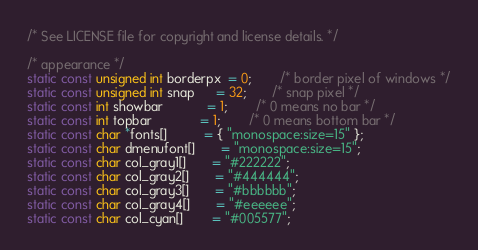<code> <loc_0><loc_0><loc_500><loc_500><_C_>/* See LICENSE file for copyright and license details. */

/* appearance */
static const unsigned int borderpx  = 0;        /* border pixel of windows */
static const unsigned int snap      = 32;       /* snap pixel */
static const int showbar            = 1;        /* 0 means no bar */
static const int topbar             = 1;        /* 0 means bottom bar */
static const char *fonts[]          = { "monospace:size=15" };
static const char dmenufont[]       = "monospace:size=15";
static const char col_gray1[]       = "#222222";
static const char col_gray2[]       = "#444444";
static const char col_gray3[]       = "#bbbbbb";
static const char col_gray4[]       = "#eeeeee";
static const char col_cyan[]        = "#005577";</code> 